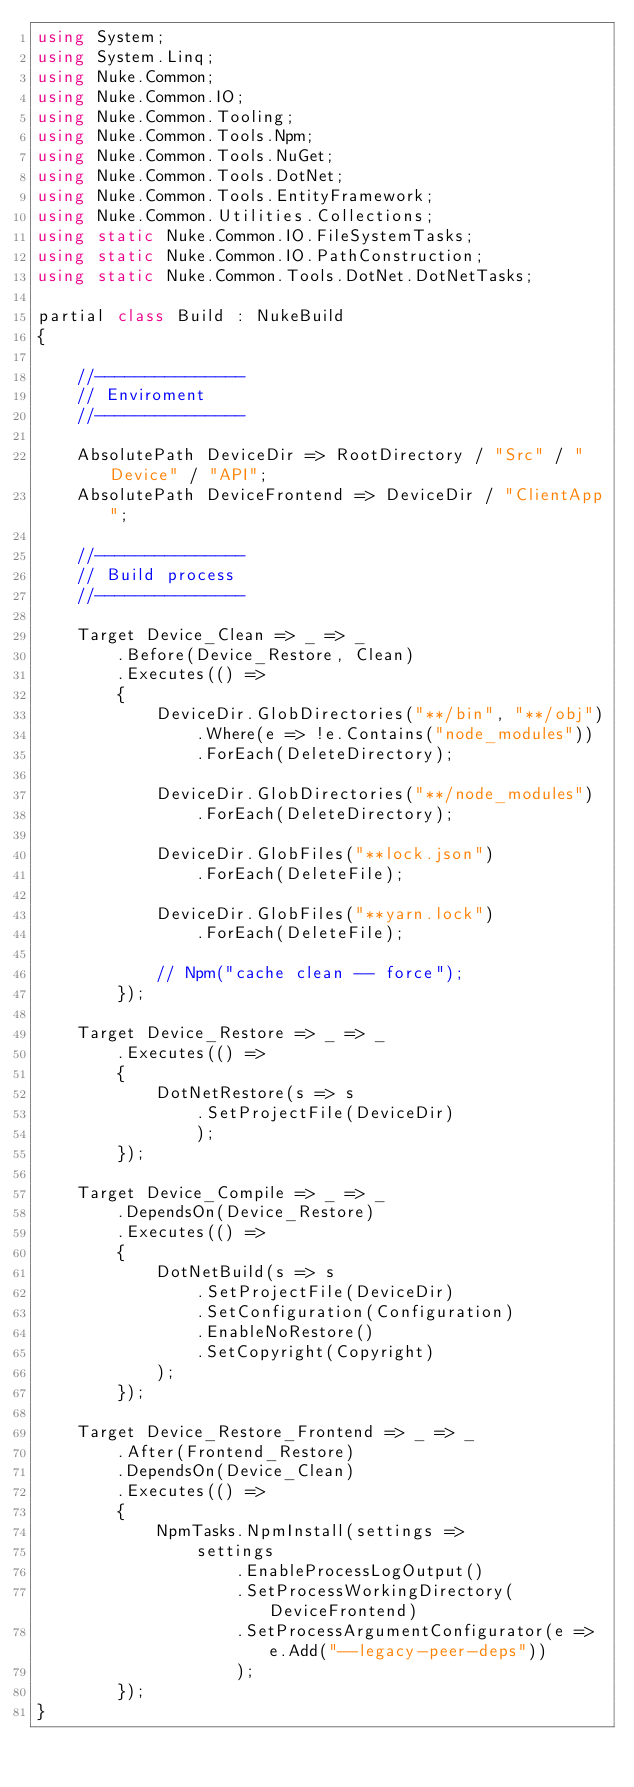<code> <loc_0><loc_0><loc_500><loc_500><_C#_>using System;
using System.Linq;
using Nuke.Common;
using Nuke.Common.IO;
using Nuke.Common.Tooling;
using Nuke.Common.Tools.Npm;
using Nuke.Common.Tools.NuGet;
using Nuke.Common.Tools.DotNet;
using Nuke.Common.Tools.EntityFramework;
using Nuke.Common.Utilities.Collections;
using static Nuke.Common.IO.FileSystemTasks;
using static Nuke.Common.IO.PathConstruction;
using static Nuke.Common.Tools.DotNet.DotNetTasks;

partial class Build : NukeBuild
{

    //---------------
    // Enviroment
    //---------------

    AbsolutePath DeviceDir => RootDirectory / "Src" / "Device" / "API";
    AbsolutePath DeviceFrontend => DeviceDir / "ClientApp";

    //---------------
    // Build process
    //---------------

    Target Device_Clean => _ => _
        .Before(Device_Restore, Clean)
        .Executes(() =>
        {
            DeviceDir.GlobDirectories("**/bin", "**/obj")
                .Where(e => !e.Contains("node_modules"))
                .ForEach(DeleteDirectory);

            DeviceDir.GlobDirectories("**/node_modules")
                .ForEach(DeleteDirectory);

            DeviceDir.GlobFiles("**lock.json")
                .ForEach(DeleteFile);

            DeviceDir.GlobFiles("**yarn.lock")
                .ForEach(DeleteFile);

            // Npm("cache clean -- force");
        });

    Target Device_Restore => _ => _
        .Executes(() =>
        {
            DotNetRestore(s => s
                .SetProjectFile(DeviceDir)
                );
        });

    Target Device_Compile => _ => _
        .DependsOn(Device_Restore)
        .Executes(() =>
        {
            DotNetBuild(s => s
                .SetProjectFile(DeviceDir)
                .SetConfiguration(Configuration)
                .EnableNoRestore()
                .SetCopyright(Copyright)
            );
        });

    Target Device_Restore_Frontend => _ => _
        .After(Frontend_Restore)
        .DependsOn(Device_Clean)
        .Executes(() =>
        {
            NpmTasks.NpmInstall(settings =>
                settings
                    .EnableProcessLogOutput()
                    .SetProcessWorkingDirectory(DeviceFrontend)
                    .SetProcessArgumentConfigurator(e => e.Add("--legacy-peer-deps"))
                    );
        });
}
</code> 